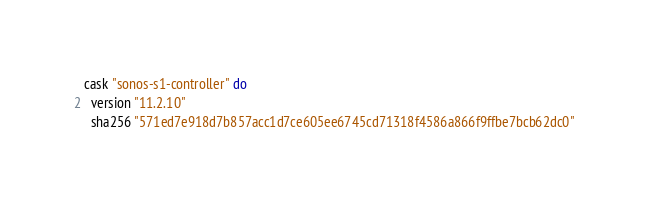Convert code to text. <code><loc_0><loc_0><loc_500><loc_500><_Ruby_>cask "sonos-s1-controller" do
  version "11.2.10"
  sha256 "571ed7e918d7b857acc1d7ce605ee6745cd71318f4586a866f9ffbe7bcb62dc0"
</code> 